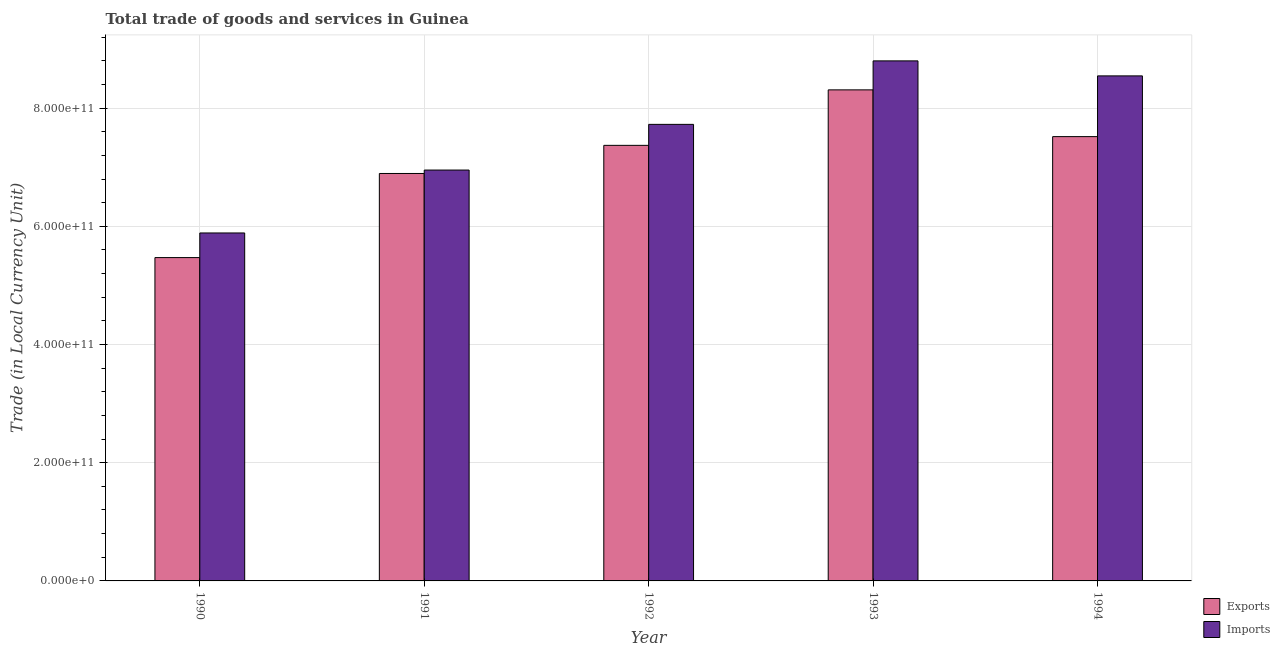How many groups of bars are there?
Your response must be concise. 5. Are the number of bars per tick equal to the number of legend labels?
Provide a succinct answer. Yes. Are the number of bars on each tick of the X-axis equal?
Provide a short and direct response. Yes. In how many cases, is the number of bars for a given year not equal to the number of legend labels?
Your answer should be very brief. 0. What is the export of goods and services in 1990?
Give a very brief answer. 5.47e+11. Across all years, what is the maximum export of goods and services?
Your response must be concise. 8.31e+11. Across all years, what is the minimum export of goods and services?
Provide a succinct answer. 5.47e+11. What is the total export of goods and services in the graph?
Provide a short and direct response. 3.56e+12. What is the difference between the imports of goods and services in 1990 and that in 1991?
Provide a short and direct response. -1.06e+11. What is the difference between the export of goods and services in 1994 and the imports of goods and services in 1991?
Offer a very short reply. 6.24e+1. What is the average export of goods and services per year?
Your response must be concise. 7.11e+11. In how many years, is the imports of goods and services greater than 840000000000 LCU?
Ensure brevity in your answer.  2. What is the ratio of the imports of goods and services in 1993 to that in 1994?
Provide a succinct answer. 1.03. What is the difference between the highest and the second highest export of goods and services?
Your answer should be very brief. 7.91e+1. What is the difference between the highest and the lowest imports of goods and services?
Your answer should be very brief. 2.91e+11. What does the 1st bar from the left in 1990 represents?
Ensure brevity in your answer.  Exports. What does the 1st bar from the right in 1993 represents?
Offer a very short reply. Imports. How many bars are there?
Offer a terse response. 10. Are all the bars in the graph horizontal?
Provide a short and direct response. No. What is the difference between two consecutive major ticks on the Y-axis?
Keep it short and to the point. 2.00e+11. Are the values on the major ticks of Y-axis written in scientific E-notation?
Provide a short and direct response. Yes. Does the graph contain any zero values?
Provide a short and direct response. No. What is the title of the graph?
Your answer should be compact. Total trade of goods and services in Guinea. Does "Crop" appear as one of the legend labels in the graph?
Your response must be concise. No. What is the label or title of the Y-axis?
Your answer should be very brief. Trade (in Local Currency Unit). What is the Trade (in Local Currency Unit) of Exports in 1990?
Give a very brief answer. 5.47e+11. What is the Trade (in Local Currency Unit) in Imports in 1990?
Provide a short and direct response. 5.89e+11. What is the Trade (in Local Currency Unit) in Exports in 1991?
Offer a terse response. 6.89e+11. What is the Trade (in Local Currency Unit) in Imports in 1991?
Provide a succinct answer. 6.95e+11. What is the Trade (in Local Currency Unit) in Exports in 1992?
Your response must be concise. 7.37e+11. What is the Trade (in Local Currency Unit) of Imports in 1992?
Make the answer very short. 7.72e+11. What is the Trade (in Local Currency Unit) of Exports in 1993?
Offer a terse response. 8.31e+11. What is the Trade (in Local Currency Unit) of Imports in 1993?
Give a very brief answer. 8.80e+11. What is the Trade (in Local Currency Unit) of Exports in 1994?
Give a very brief answer. 7.52e+11. What is the Trade (in Local Currency Unit) of Imports in 1994?
Ensure brevity in your answer.  8.55e+11. Across all years, what is the maximum Trade (in Local Currency Unit) of Exports?
Ensure brevity in your answer.  8.31e+11. Across all years, what is the maximum Trade (in Local Currency Unit) in Imports?
Keep it short and to the point. 8.80e+11. Across all years, what is the minimum Trade (in Local Currency Unit) of Exports?
Give a very brief answer. 5.47e+11. Across all years, what is the minimum Trade (in Local Currency Unit) of Imports?
Your answer should be compact. 5.89e+11. What is the total Trade (in Local Currency Unit) of Exports in the graph?
Your answer should be compact. 3.56e+12. What is the total Trade (in Local Currency Unit) of Imports in the graph?
Your answer should be compact. 3.79e+12. What is the difference between the Trade (in Local Currency Unit) in Exports in 1990 and that in 1991?
Your answer should be very brief. -1.42e+11. What is the difference between the Trade (in Local Currency Unit) in Imports in 1990 and that in 1991?
Your answer should be compact. -1.06e+11. What is the difference between the Trade (in Local Currency Unit) in Exports in 1990 and that in 1992?
Your answer should be compact. -1.90e+11. What is the difference between the Trade (in Local Currency Unit) in Imports in 1990 and that in 1992?
Ensure brevity in your answer.  -1.84e+11. What is the difference between the Trade (in Local Currency Unit) of Exports in 1990 and that in 1993?
Ensure brevity in your answer.  -2.84e+11. What is the difference between the Trade (in Local Currency Unit) of Imports in 1990 and that in 1993?
Offer a terse response. -2.91e+11. What is the difference between the Trade (in Local Currency Unit) of Exports in 1990 and that in 1994?
Provide a short and direct response. -2.05e+11. What is the difference between the Trade (in Local Currency Unit) of Imports in 1990 and that in 1994?
Provide a short and direct response. -2.66e+11. What is the difference between the Trade (in Local Currency Unit) in Exports in 1991 and that in 1992?
Offer a terse response. -4.76e+1. What is the difference between the Trade (in Local Currency Unit) of Imports in 1991 and that in 1992?
Your answer should be very brief. -7.73e+1. What is the difference between the Trade (in Local Currency Unit) of Exports in 1991 and that in 1993?
Keep it short and to the point. -1.41e+11. What is the difference between the Trade (in Local Currency Unit) of Imports in 1991 and that in 1993?
Make the answer very short. -1.85e+11. What is the difference between the Trade (in Local Currency Unit) of Exports in 1991 and that in 1994?
Give a very brief answer. -6.24e+1. What is the difference between the Trade (in Local Currency Unit) in Imports in 1991 and that in 1994?
Your response must be concise. -1.59e+11. What is the difference between the Trade (in Local Currency Unit) of Exports in 1992 and that in 1993?
Keep it short and to the point. -9.39e+1. What is the difference between the Trade (in Local Currency Unit) of Imports in 1992 and that in 1993?
Make the answer very short. -1.07e+11. What is the difference between the Trade (in Local Currency Unit) of Exports in 1992 and that in 1994?
Make the answer very short. -1.48e+1. What is the difference between the Trade (in Local Currency Unit) of Imports in 1992 and that in 1994?
Your answer should be very brief. -8.20e+1. What is the difference between the Trade (in Local Currency Unit) in Exports in 1993 and that in 1994?
Your answer should be compact. 7.91e+1. What is the difference between the Trade (in Local Currency Unit) in Imports in 1993 and that in 1994?
Make the answer very short. 2.54e+1. What is the difference between the Trade (in Local Currency Unit) of Exports in 1990 and the Trade (in Local Currency Unit) of Imports in 1991?
Your response must be concise. -1.48e+11. What is the difference between the Trade (in Local Currency Unit) of Exports in 1990 and the Trade (in Local Currency Unit) of Imports in 1992?
Offer a very short reply. -2.25e+11. What is the difference between the Trade (in Local Currency Unit) of Exports in 1990 and the Trade (in Local Currency Unit) of Imports in 1993?
Your answer should be very brief. -3.33e+11. What is the difference between the Trade (in Local Currency Unit) of Exports in 1990 and the Trade (in Local Currency Unit) of Imports in 1994?
Ensure brevity in your answer.  -3.07e+11. What is the difference between the Trade (in Local Currency Unit) of Exports in 1991 and the Trade (in Local Currency Unit) of Imports in 1992?
Your response must be concise. -8.31e+1. What is the difference between the Trade (in Local Currency Unit) in Exports in 1991 and the Trade (in Local Currency Unit) in Imports in 1993?
Your response must be concise. -1.91e+11. What is the difference between the Trade (in Local Currency Unit) in Exports in 1991 and the Trade (in Local Currency Unit) in Imports in 1994?
Your response must be concise. -1.65e+11. What is the difference between the Trade (in Local Currency Unit) of Exports in 1992 and the Trade (in Local Currency Unit) of Imports in 1993?
Give a very brief answer. -1.43e+11. What is the difference between the Trade (in Local Currency Unit) of Exports in 1992 and the Trade (in Local Currency Unit) of Imports in 1994?
Offer a terse response. -1.18e+11. What is the difference between the Trade (in Local Currency Unit) of Exports in 1993 and the Trade (in Local Currency Unit) of Imports in 1994?
Give a very brief answer. -2.36e+1. What is the average Trade (in Local Currency Unit) in Exports per year?
Keep it short and to the point. 7.11e+11. What is the average Trade (in Local Currency Unit) of Imports per year?
Ensure brevity in your answer.  7.58e+11. In the year 1990, what is the difference between the Trade (in Local Currency Unit) in Exports and Trade (in Local Currency Unit) in Imports?
Keep it short and to the point. -4.17e+1. In the year 1991, what is the difference between the Trade (in Local Currency Unit) in Exports and Trade (in Local Currency Unit) in Imports?
Make the answer very short. -5.79e+09. In the year 1992, what is the difference between the Trade (in Local Currency Unit) in Exports and Trade (in Local Currency Unit) in Imports?
Your answer should be very brief. -3.55e+1. In the year 1993, what is the difference between the Trade (in Local Currency Unit) in Exports and Trade (in Local Currency Unit) in Imports?
Make the answer very short. -4.90e+1. In the year 1994, what is the difference between the Trade (in Local Currency Unit) in Exports and Trade (in Local Currency Unit) in Imports?
Provide a succinct answer. -1.03e+11. What is the ratio of the Trade (in Local Currency Unit) of Exports in 1990 to that in 1991?
Make the answer very short. 0.79. What is the ratio of the Trade (in Local Currency Unit) in Imports in 1990 to that in 1991?
Provide a short and direct response. 0.85. What is the ratio of the Trade (in Local Currency Unit) in Exports in 1990 to that in 1992?
Your answer should be very brief. 0.74. What is the ratio of the Trade (in Local Currency Unit) of Imports in 1990 to that in 1992?
Your answer should be very brief. 0.76. What is the ratio of the Trade (in Local Currency Unit) in Exports in 1990 to that in 1993?
Your answer should be compact. 0.66. What is the ratio of the Trade (in Local Currency Unit) in Imports in 1990 to that in 1993?
Give a very brief answer. 0.67. What is the ratio of the Trade (in Local Currency Unit) in Exports in 1990 to that in 1994?
Your response must be concise. 0.73. What is the ratio of the Trade (in Local Currency Unit) of Imports in 1990 to that in 1994?
Keep it short and to the point. 0.69. What is the ratio of the Trade (in Local Currency Unit) in Exports in 1991 to that in 1992?
Give a very brief answer. 0.94. What is the ratio of the Trade (in Local Currency Unit) in Imports in 1991 to that in 1992?
Your answer should be compact. 0.9. What is the ratio of the Trade (in Local Currency Unit) in Exports in 1991 to that in 1993?
Keep it short and to the point. 0.83. What is the ratio of the Trade (in Local Currency Unit) of Imports in 1991 to that in 1993?
Offer a very short reply. 0.79. What is the ratio of the Trade (in Local Currency Unit) of Exports in 1991 to that in 1994?
Keep it short and to the point. 0.92. What is the ratio of the Trade (in Local Currency Unit) in Imports in 1991 to that in 1994?
Keep it short and to the point. 0.81. What is the ratio of the Trade (in Local Currency Unit) of Exports in 1992 to that in 1993?
Your answer should be compact. 0.89. What is the ratio of the Trade (in Local Currency Unit) in Imports in 1992 to that in 1993?
Offer a very short reply. 0.88. What is the ratio of the Trade (in Local Currency Unit) in Exports in 1992 to that in 1994?
Ensure brevity in your answer.  0.98. What is the ratio of the Trade (in Local Currency Unit) of Imports in 1992 to that in 1994?
Offer a very short reply. 0.9. What is the ratio of the Trade (in Local Currency Unit) of Exports in 1993 to that in 1994?
Offer a terse response. 1.11. What is the ratio of the Trade (in Local Currency Unit) of Imports in 1993 to that in 1994?
Your response must be concise. 1.03. What is the difference between the highest and the second highest Trade (in Local Currency Unit) of Exports?
Give a very brief answer. 7.91e+1. What is the difference between the highest and the second highest Trade (in Local Currency Unit) of Imports?
Provide a short and direct response. 2.54e+1. What is the difference between the highest and the lowest Trade (in Local Currency Unit) in Exports?
Your response must be concise. 2.84e+11. What is the difference between the highest and the lowest Trade (in Local Currency Unit) in Imports?
Offer a very short reply. 2.91e+11. 